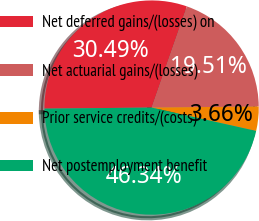Convert chart to OTSL. <chart><loc_0><loc_0><loc_500><loc_500><pie_chart><fcel>Net deferred gains/(losses) on<fcel>Net actuarial gains/(losses)<fcel>Prior service credits/(costs)<fcel>Net postemployment benefit<nl><fcel>30.49%<fcel>19.51%<fcel>3.66%<fcel>46.34%<nl></chart> 